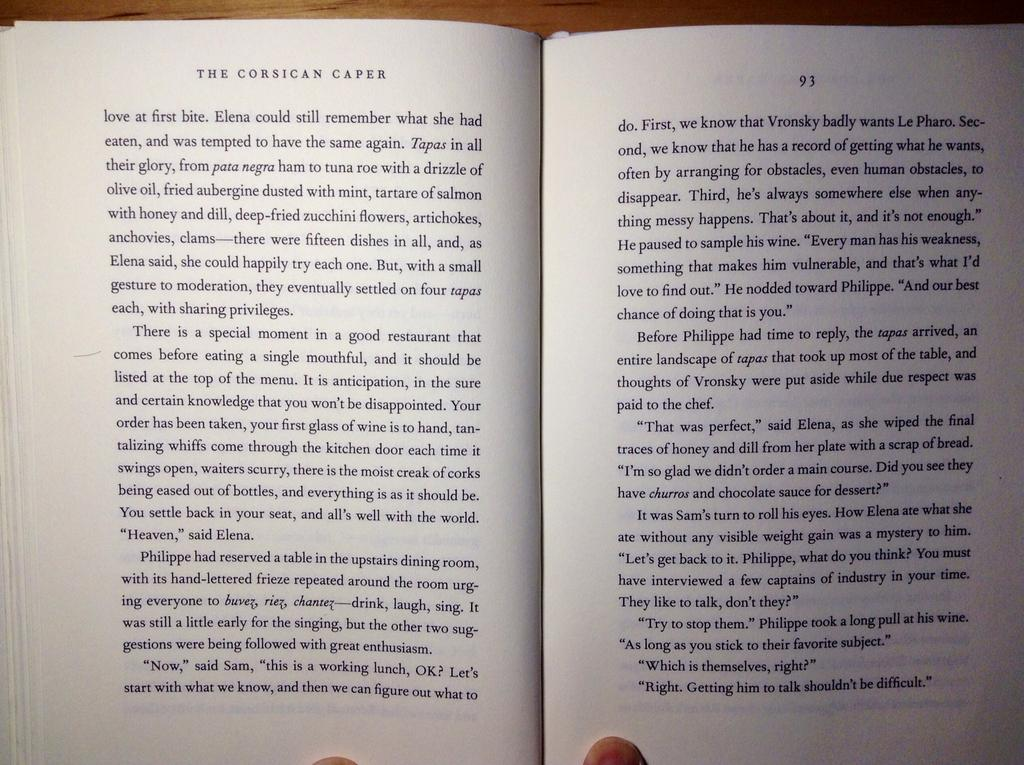<image>
Write a terse but informative summary of the picture. Pages of a book that include page numbers 92 and 93. 